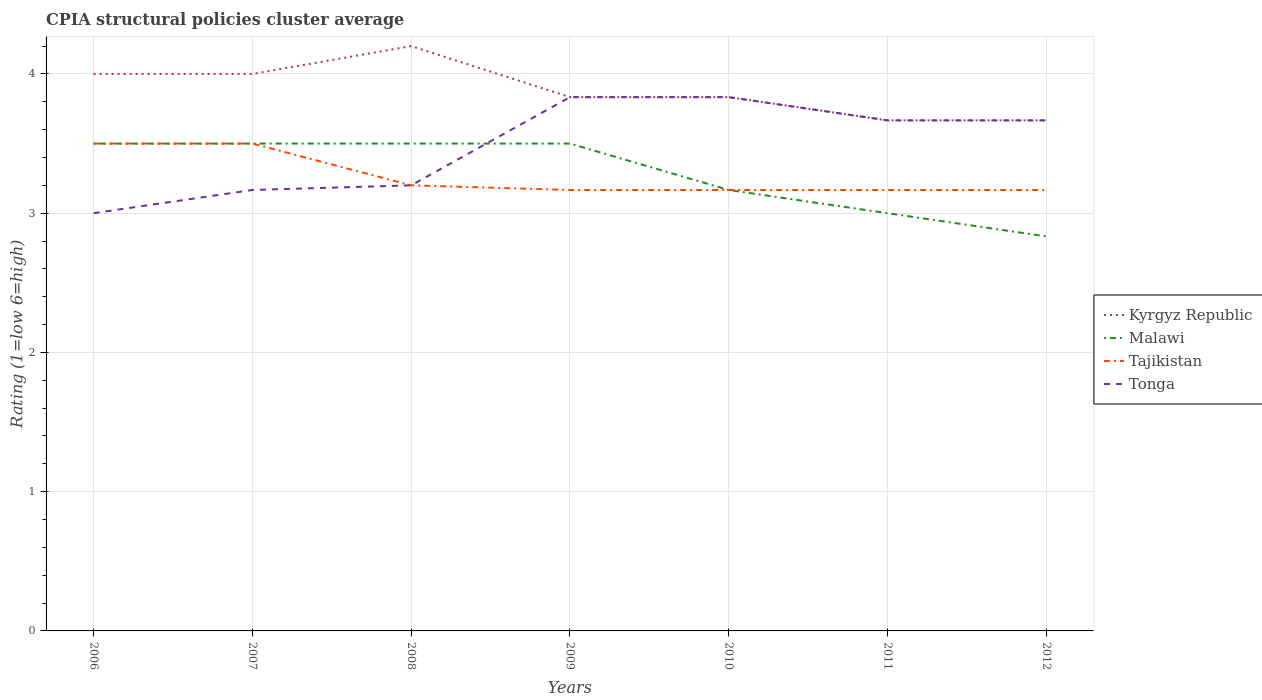Does the line corresponding to Malawi intersect with the line corresponding to Kyrgyz Republic?
Your answer should be very brief. No. Across all years, what is the maximum CPIA rating in Kyrgyz Republic?
Offer a very short reply. 3.67. In which year was the CPIA rating in Tajikistan maximum?
Ensure brevity in your answer.  2009. What is the difference between the highest and the second highest CPIA rating in Kyrgyz Republic?
Your response must be concise. 0.53. Is the CPIA rating in Kyrgyz Republic strictly greater than the CPIA rating in Tajikistan over the years?
Provide a succinct answer. No. How many years are there in the graph?
Your response must be concise. 7. What is the difference between two consecutive major ticks on the Y-axis?
Offer a terse response. 1. Does the graph contain any zero values?
Your answer should be very brief. No. Where does the legend appear in the graph?
Keep it short and to the point. Center right. How are the legend labels stacked?
Offer a terse response. Vertical. What is the title of the graph?
Ensure brevity in your answer.  CPIA structural policies cluster average. What is the label or title of the Y-axis?
Provide a succinct answer. Rating (1=low 6=high). What is the Rating (1=low 6=high) in Malawi in 2006?
Offer a terse response. 3.5. What is the Rating (1=low 6=high) in Tajikistan in 2006?
Keep it short and to the point. 3.5. What is the Rating (1=low 6=high) of Tonga in 2006?
Ensure brevity in your answer.  3. What is the Rating (1=low 6=high) of Kyrgyz Republic in 2007?
Your response must be concise. 4. What is the Rating (1=low 6=high) in Malawi in 2007?
Make the answer very short. 3.5. What is the Rating (1=low 6=high) of Tajikistan in 2007?
Provide a short and direct response. 3.5. What is the Rating (1=low 6=high) in Tonga in 2007?
Provide a succinct answer. 3.17. What is the Rating (1=low 6=high) in Kyrgyz Republic in 2008?
Give a very brief answer. 4.2. What is the Rating (1=low 6=high) in Kyrgyz Republic in 2009?
Keep it short and to the point. 3.83. What is the Rating (1=low 6=high) of Tajikistan in 2009?
Your answer should be very brief. 3.17. What is the Rating (1=low 6=high) in Tonga in 2009?
Make the answer very short. 3.83. What is the Rating (1=low 6=high) in Kyrgyz Republic in 2010?
Ensure brevity in your answer.  3.83. What is the Rating (1=low 6=high) in Malawi in 2010?
Provide a succinct answer. 3.17. What is the Rating (1=low 6=high) in Tajikistan in 2010?
Ensure brevity in your answer.  3.17. What is the Rating (1=low 6=high) of Tonga in 2010?
Give a very brief answer. 3.83. What is the Rating (1=low 6=high) of Kyrgyz Republic in 2011?
Give a very brief answer. 3.67. What is the Rating (1=low 6=high) of Malawi in 2011?
Your answer should be compact. 3. What is the Rating (1=low 6=high) of Tajikistan in 2011?
Your answer should be very brief. 3.17. What is the Rating (1=low 6=high) of Tonga in 2011?
Provide a succinct answer. 3.67. What is the Rating (1=low 6=high) in Kyrgyz Republic in 2012?
Ensure brevity in your answer.  3.67. What is the Rating (1=low 6=high) of Malawi in 2012?
Offer a very short reply. 2.83. What is the Rating (1=low 6=high) of Tajikistan in 2012?
Your response must be concise. 3.17. What is the Rating (1=low 6=high) of Tonga in 2012?
Your answer should be very brief. 3.67. Across all years, what is the maximum Rating (1=low 6=high) of Kyrgyz Republic?
Provide a short and direct response. 4.2. Across all years, what is the maximum Rating (1=low 6=high) of Tajikistan?
Your response must be concise. 3.5. Across all years, what is the maximum Rating (1=low 6=high) in Tonga?
Offer a terse response. 3.83. Across all years, what is the minimum Rating (1=low 6=high) of Kyrgyz Republic?
Provide a short and direct response. 3.67. Across all years, what is the minimum Rating (1=low 6=high) of Malawi?
Offer a terse response. 2.83. Across all years, what is the minimum Rating (1=low 6=high) in Tajikistan?
Make the answer very short. 3.17. What is the total Rating (1=low 6=high) of Kyrgyz Republic in the graph?
Give a very brief answer. 27.2. What is the total Rating (1=low 6=high) of Tajikistan in the graph?
Keep it short and to the point. 22.87. What is the total Rating (1=low 6=high) in Tonga in the graph?
Ensure brevity in your answer.  24.37. What is the difference between the Rating (1=low 6=high) in Malawi in 2006 and that in 2007?
Your answer should be very brief. 0. What is the difference between the Rating (1=low 6=high) of Tajikistan in 2006 and that in 2007?
Make the answer very short. 0. What is the difference between the Rating (1=low 6=high) in Tonga in 2006 and that in 2007?
Your response must be concise. -0.17. What is the difference between the Rating (1=low 6=high) in Malawi in 2006 and that in 2008?
Provide a succinct answer. 0. What is the difference between the Rating (1=low 6=high) in Tonga in 2006 and that in 2008?
Your response must be concise. -0.2. What is the difference between the Rating (1=low 6=high) of Malawi in 2006 and that in 2009?
Offer a terse response. 0. What is the difference between the Rating (1=low 6=high) in Kyrgyz Republic in 2006 and that in 2010?
Your response must be concise. 0.17. What is the difference between the Rating (1=low 6=high) in Tajikistan in 2006 and that in 2010?
Your response must be concise. 0.33. What is the difference between the Rating (1=low 6=high) in Kyrgyz Republic in 2006 and that in 2011?
Provide a succinct answer. 0.33. What is the difference between the Rating (1=low 6=high) of Malawi in 2006 and that in 2011?
Your answer should be compact. 0.5. What is the difference between the Rating (1=low 6=high) of Tonga in 2006 and that in 2011?
Provide a succinct answer. -0.67. What is the difference between the Rating (1=low 6=high) in Malawi in 2006 and that in 2012?
Your response must be concise. 0.67. What is the difference between the Rating (1=low 6=high) in Tonga in 2006 and that in 2012?
Your response must be concise. -0.67. What is the difference between the Rating (1=low 6=high) of Tajikistan in 2007 and that in 2008?
Your answer should be compact. 0.3. What is the difference between the Rating (1=low 6=high) in Tonga in 2007 and that in 2008?
Provide a succinct answer. -0.03. What is the difference between the Rating (1=low 6=high) in Kyrgyz Republic in 2007 and that in 2009?
Provide a succinct answer. 0.17. What is the difference between the Rating (1=low 6=high) of Tajikistan in 2007 and that in 2009?
Offer a terse response. 0.33. What is the difference between the Rating (1=low 6=high) of Tonga in 2007 and that in 2009?
Ensure brevity in your answer.  -0.67. What is the difference between the Rating (1=low 6=high) in Tajikistan in 2007 and that in 2010?
Make the answer very short. 0.33. What is the difference between the Rating (1=low 6=high) in Tonga in 2007 and that in 2010?
Your answer should be compact. -0.67. What is the difference between the Rating (1=low 6=high) in Kyrgyz Republic in 2007 and that in 2011?
Your response must be concise. 0.33. What is the difference between the Rating (1=low 6=high) in Malawi in 2007 and that in 2011?
Offer a terse response. 0.5. What is the difference between the Rating (1=low 6=high) of Tonga in 2007 and that in 2011?
Give a very brief answer. -0.5. What is the difference between the Rating (1=low 6=high) in Malawi in 2007 and that in 2012?
Your response must be concise. 0.67. What is the difference between the Rating (1=low 6=high) in Kyrgyz Republic in 2008 and that in 2009?
Give a very brief answer. 0.37. What is the difference between the Rating (1=low 6=high) in Tajikistan in 2008 and that in 2009?
Your answer should be compact. 0.03. What is the difference between the Rating (1=low 6=high) in Tonga in 2008 and that in 2009?
Ensure brevity in your answer.  -0.63. What is the difference between the Rating (1=low 6=high) of Kyrgyz Republic in 2008 and that in 2010?
Your response must be concise. 0.37. What is the difference between the Rating (1=low 6=high) of Malawi in 2008 and that in 2010?
Offer a terse response. 0.33. What is the difference between the Rating (1=low 6=high) in Tajikistan in 2008 and that in 2010?
Your answer should be compact. 0.03. What is the difference between the Rating (1=low 6=high) in Tonga in 2008 and that in 2010?
Ensure brevity in your answer.  -0.63. What is the difference between the Rating (1=low 6=high) of Kyrgyz Republic in 2008 and that in 2011?
Provide a short and direct response. 0.53. What is the difference between the Rating (1=low 6=high) in Malawi in 2008 and that in 2011?
Your response must be concise. 0.5. What is the difference between the Rating (1=low 6=high) of Tonga in 2008 and that in 2011?
Provide a succinct answer. -0.47. What is the difference between the Rating (1=low 6=high) in Kyrgyz Republic in 2008 and that in 2012?
Ensure brevity in your answer.  0.53. What is the difference between the Rating (1=low 6=high) of Tonga in 2008 and that in 2012?
Your response must be concise. -0.47. What is the difference between the Rating (1=low 6=high) in Kyrgyz Republic in 2009 and that in 2010?
Offer a terse response. 0. What is the difference between the Rating (1=low 6=high) of Kyrgyz Republic in 2009 and that in 2011?
Ensure brevity in your answer.  0.17. What is the difference between the Rating (1=low 6=high) of Tajikistan in 2009 and that in 2011?
Ensure brevity in your answer.  0. What is the difference between the Rating (1=low 6=high) in Tonga in 2009 and that in 2011?
Your response must be concise. 0.17. What is the difference between the Rating (1=low 6=high) of Tonga in 2009 and that in 2012?
Provide a short and direct response. 0.17. What is the difference between the Rating (1=low 6=high) in Malawi in 2010 and that in 2011?
Give a very brief answer. 0.17. What is the difference between the Rating (1=low 6=high) of Tajikistan in 2010 and that in 2011?
Offer a terse response. 0. What is the difference between the Rating (1=low 6=high) in Tonga in 2010 and that in 2011?
Give a very brief answer. 0.17. What is the difference between the Rating (1=low 6=high) of Malawi in 2010 and that in 2012?
Your answer should be compact. 0.33. What is the difference between the Rating (1=low 6=high) in Tajikistan in 2010 and that in 2012?
Make the answer very short. 0. What is the difference between the Rating (1=low 6=high) in Kyrgyz Republic in 2011 and that in 2012?
Provide a short and direct response. 0. What is the difference between the Rating (1=low 6=high) of Malawi in 2011 and that in 2012?
Offer a very short reply. 0.17. What is the difference between the Rating (1=low 6=high) of Tonga in 2011 and that in 2012?
Your answer should be very brief. 0. What is the difference between the Rating (1=low 6=high) of Kyrgyz Republic in 2006 and the Rating (1=low 6=high) of Tajikistan in 2007?
Offer a terse response. 0.5. What is the difference between the Rating (1=low 6=high) of Malawi in 2006 and the Rating (1=low 6=high) of Tonga in 2007?
Provide a succinct answer. 0.33. What is the difference between the Rating (1=low 6=high) in Kyrgyz Republic in 2006 and the Rating (1=low 6=high) in Tonga in 2008?
Ensure brevity in your answer.  0.8. What is the difference between the Rating (1=low 6=high) of Malawi in 2006 and the Rating (1=low 6=high) of Tajikistan in 2008?
Your response must be concise. 0.3. What is the difference between the Rating (1=low 6=high) in Malawi in 2006 and the Rating (1=low 6=high) in Tonga in 2008?
Give a very brief answer. 0.3. What is the difference between the Rating (1=low 6=high) of Kyrgyz Republic in 2006 and the Rating (1=low 6=high) of Tajikistan in 2009?
Your answer should be compact. 0.83. What is the difference between the Rating (1=low 6=high) in Malawi in 2006 and the Rating (1=low 6=high) in Tajikistan in 2009?
Your answer should be compact. 0.33. What is the difference between the Rating (1=low 6=high) in Tajikistan in 2006 and the Rating (1=low 6=high) in Tonga in 2009?
Offer a very short reply. -0.33. What is the difference between the Rating (1=low 6=high) of Kyrgyz Republic in 2006 and the Rating (1=low 6=high) of Tonga in 2010?
Give a very brief answer. 0.17. What is the difference between the Rating (1=low 6=high) of Kyrgyz Republic in 2006 and the Rating (1=low 6=high) of Malawi in 2011?
Your answer should be compact. 1. What is the difference between the Rating (1=low 6=high) of Kyrgyz Republic in 2006 and the Rating (1=low 6=high) of Tonga in 2011?
Offer a very short reply. 0.33. What is the difference between the Rating (1=low 6=high) in Malawi in 2006 and the Rating (1=low 6=high) in Tajikistan in 2011?
Offer a terse response. 0.33. What is the difference between the Rating (1=low 6=high) in Malawi in 2006 and the Rating (1=low 6=high) in Tonga in 2011?
Ensure brevity in your answer.  -0.17. What is the difference between the Rating (1=low 6=high) of Kyrgyz Republic in 2006 and the Rating (1=low 6=high) of Malawi in 2012?
Provide a short and direct response. 1.17. What is the difference between the Rating (1=low 6=high) in Malawi in 2006 and the Rating (1=low 6=high) in Tajikistan in 2012?
Provide a short and direct response. 0.33. What is the difference between the Rating (1=low 6=high) in Tajikistan in 2006 and the Rating (1=low 6=high) in Tonga in 2012?
Your response must be concise. -0.17. What is the difference between the Rating (1=low 6=high) of Kyrgyz Republic in 2007 and the Rating (1=low 6=high) of Malawi in 2008?
Keep it short and to the point. 0.5. What is the difference between the Rating (1=low 6=high) in Kyrgyz Republic in 2007 and the Rating (1=low 6=high) in Tajikistan in 2008?
Provide a succinct answer. 0.8. What is the difference between the Rating (1=low 6=high) of Kyrgyz Republic in 2007 and the Rating (1=low 6=high) of Tonga in 2008?
Provide a short and direct response. 0.8. What is the difference between the Rating (1=low 6=high) in Malawi in 2007 and the Rating (1=low 6=high) in Tajikistan in 2008?
Offer a terse response. 0.3. What is the difference between the Rating (1=low 6=high) of Kyrgyz Republic in 2007 and the Rating (1=low 6=high) of Tonga in 2009?
Offer a terse response. 0.17. What is the difference between the Rating (1=low 6=high) in Tajikistan in 2007 and the Rating (1=low 6=high) in Tonga in 2009?
Give a very brief answer. -0.33. What is the difference between the Rating (1=low 6=high) of Kyrgyz Republic in 2007 and the Rating (1=low 6=high) of Tajikistan in 2010?
Provide a succinct answer. 0.83. What is the difference between the Rating (1=low 6=high) of Kyrgyz Republic in 2007 and the Rating (1=low 6=high) of Tonga in 2010?
Provide a short and direct response. 0.17. What is the difference between the Rating (1=low 6=high) in Kyrgyz Republic in 2007 and the Rating (1=low 6=high) in Malawi in 2011?
Your answer should be very brief. 1. What is the difference between the Rating (1=low 6=high) in Kyrgyz Republic in 2007 and the Rating (1=low 6=high) in Tajikistan in 2011?
Offer a terse response. 0.83. What is the difference between the Rating (1=low 6=high) in Kyrgyz Republic in 2007 and the Rating (1=low 6=high) in Tajikistan in 2012?
Provide a succinct answer. 0.83. What is the difference between the Rating (1=low 6=high) in Kyrgyz Republic in 2007 and the Rating (1=low 6=high) in Tonga in 2012?
Make the answer very short. 0.33. What is the difference between the Rating (1=low 6=high) in Malawi in 2007 and the Rating (1=low 6=high) in Tajikistan in 2012?
Provide a short and direct response. 0.33. What is the difference between the Rating (1=low 6=high) in Malawi in 2007 and the Rating (1=low 6=high) in Tonga in 2012?
Keep it short and to the point. -0.17. What is the difference between the Rating (1=low 6=high) of Kyrgyz Republic in 2008 and the Rating (1=low 6=high) of Tonga in 2009?
Your answer should be compact. 0.37. What is the difference between the Rating (1=low 6=high) of Tajikistan in 2008 and the Rating (1=low 6=high) of Tonga in 2009?
Provide a short and direct response. -0.63. What is the difference between the Rating (1=low 6=high) in Kyrgyz Republic in 2008 and the Rating (1=low 6=high) in Malawi in 2010?
Keep it short and to the point. 1.03. What is the difference between the Rating (1=low 6=high) of Kyrgyz Republic in 2008 and the Rating (1=low 6=high) of Tonga in 2010?
Ensure brevity in your answer.  0.37. What is the difference between the Rating (1=low 6=high) of Malawi in 2008 and the Rating (1=low 6=high) of Tajikistan in 2010?
Give a very brief answer. 0.33. What is the difference between the Rating (1=low 6=high) in Malawi in 2008 and the Rating (1=low 6=high) in Tonga in 2010?
Offer a terse response. -0.33. What is the difference between the Rating (1=low 6=high) of Tajikistan in 2008 and the Rating (1=low 6=high) of Tonga in 2010?
Offer a terse response. -0.63. What is the difference between the Rating (1=low 6=high) of Kyrgyz Republic in 2008 and the Rating (1=low 6=high) of Malawi in 2011?
Ensure brevity in your answer.  1.2. What is the difference between the Rating (1=low 6=high) in Kyrgyz Republic in 2008 and the Rating (1=low 6=high) in Tajikistan in 2011?
Offer a terse response. 1.03. What is the difference between the Rating (1=low 6=high) in Kyrgyz Republic in 2008 and the Rating (1=low 6=high) in Tonga in 2011?
Give a very brief answer. 0.53. What is the difference between the Rating (1=low 6=high) in Malawi in 2008 and the Rating (1=low 6=high) in Tajikistan in 2011?
Ensure brevity in your answer.  0.33. What is the difference between the Rating (1=low 6=high) in Tajikistan in 2008 and the Rating (1=low 6=high) in Tonga in 2011?
Your response must be concise. -0.47. What is the difference between the Rating (1=low 6=high) in Kyrgyz Republic in 2008 and the Rating (1=low 6=high) in Malawi in 2012?
Your response must be concise. 1.37. What is the difference between the Rating (1=low 6=high) of Kyrgyz Republic in 2008 and the Rating (1=low 6=high) of Tajikistan in 2012?
Provide a short and direct response. 1.03. What is the difference between the Rating (1=low 6=high) in Kyrgyz Republic in 2008 and the Rating (1=low 6=high) in Tonga in 2012?
Keep it short and to the point. 0.53. What is the difference between the Rating (1=low 6=high) in Malawi in 2008 and the Rating (1=low 6=high) in Tajikistan in 2012?
Keep it short and to the point. 0.33. What is the difference between the Rating (1=low 6=high) in Malawi in 2008 and the Rating (1=low 6=high) in Tonga in 2012?
Your answer should be very brief. -0.17. What is the difference between the Rating (1=low 6=high) in Tajikistan in 2008 and the Rating (1=low 6=high) in Tonga in 2012?
Ensure brevity in your answer.  -0.47. What is the difference between the Rating (1=low 6=high) of Kyrgyz Republic in 2009 and the Rating (1=low 6=high) of Tajikistan in 2010?
Offer a very short reply. 0.67. What is the difference between the Rating (1=low 6=high) in Malawi in 2009 and the Rating (1=low 6=high) in Tajikistan in 2010?
Provide a succinct answer. 0.33. What is the difference between the Rating (1=low 6=high) of Tajikistan in 2009 and the Rating (1=low 6=high) of Tonga in 2010?
Provide a short and direct response. -0.67. What is the difference between the Rating (1=low 6=high) of Kyrgyz Republic in 2009 and the Rating (1=low 6=high) of Malawi in 2011?
Give a very brief answer. 0.83. What is the difference between the Rating (1=low 6=high) in Kyrgyz Republic in 2009 and the Rating (1=low 6=high) in Tajikistan in 2011?
Offer a terse response. 0.67. What is the difference between the Rating (1=low 6=high) in Malawi in 2009 and the Rating (1=low 6=high) in Tonga in 2011?
Your response must be concise. -0.17. What is the difference between the Rating (1=low 6=high) in Kyrgyz Republic in 2009 and the Rating (1=low 6=high) in Malawi in 2012?
Ensure brevity in your answer.  1. What is the difference between the Rating (1=low 6=high) in Kyrgyz Republic in 2009 and the Rating (1=low 6=high) in Tajikistan in 2012?
Ensure brevity in your answer.  0.67. What is the difference between the Rating (1=low 6=high) in Malawi in 2009 and the Rating (1=low 6=high) in Tajikistan in 2012?
Offer a terse response. 0.33. What is the difference between the Rating (1=low 6=high) in Tajikistan in 2009 and the Rating (1=low 6=high) in Tonga in 2012?
Offer a terse response. -0.5. What is the difference between the Rating (1=low 6=high) of Kyrgyz Republic in 2010 and the Rating (1=low 6=high) of Tonga in 2011?
Ensure brevity in your answer.  0.17. What is the difference between the Rating (1=low 6=high) of Malawi in 2010 and the Rating (1=low 6=high) of Tajikistan in 2011?
Your answer should be very brief. 0. What is the difference between the Rating (1=low 6=high) in Malawi in 2010 and the Rating (1=low 6=high) in Tonga in 2011?
Provide a succinct answer. -0.5. What is the difference between the Rating (1=low 6=high) of Malawi in 2010 and the Rating (1=low 6=high) of Tajikistan in 2012?
Offer a terse response. 0. What is the difference between the Rating (1=low 6=high) of Malawi in 2010 and the Rating (1=low 6=high) of Tonga in 2012?
Your answer should be very brief. -0.5. What is the difference between the Rating (1=low 6=high) in Tajikistan in 2010 and the Rating (1=low 6=high) in Tonga in 2012?
Make the answer very short. -0.5. What is the difference between the Rating (1=low 6=high) of Kyrgyz Republic in 2011 and the Rating (1=low 6=high) of Malawi in 2012?
Provide a succinct answer. 0.83. What is the difference between the Rating (1=low 6=high) of Kyrgyz Republic in 2011 and the Rating (1=low 6=high) of Tajikistan in 2012?
Keep it short and to the point. 0.5. What is the difference between the Rating (1=low 6=high) in Tajikistan in 2011 and the Rating (1=low 6=high) in Tonga in 2012?
Provide a short and direct response. -0.5. What is the average Rating (1=low 6=high) of Kyrgyz Republic per year?
Provide a short and direct response. 3.89. What is the average Rating (1=low 6=high) of Malawi per year?
Your response must be concise. 3.29. What is the average Rating (1=low 6=high) of Tajikistan per year?
Make the answer very short. 3.27. What is the average Rating (1=low 6=high) in Tonga per year?
Provide a succinct answer. 3.48. In the year 2006, what is the difference between the Rating (1=low 6=high) of Kyrgyz Republic and Rating (1=low 6=high) of Malawi?
Keep it short and to the point. 0.5. In the year 2006, what is the difference between the Rating (1=low 6=high) of Kyrgyz Republic and Rating (1=low 6=high) of Tonga?
Your answer should be compact. 1. In the year 2006, what is the difference between the Rating (1=low 6=high) in Malawi and Rating (1=low 6=high) in Tonga?
Your response must be concise. 0.5. In the year 2007, what is the difference between the Rating (1=low 6=high) in Kyrgyz Republic and Rating (1=low 6=high) in Tajikistan?
Provide a succinct answer. 0.5. In the year 2007, what is the difference between the Rating (1=low 6=high) in Kyrgyz Republic and Rating (1=low 6=high) in Tonga?
Your answer should be very brief. 0.83. In the year 2007, what is the difference between the Rating (1=low 6=high) of Malawi and Rating (1=low 6=high) of Tajikistan?
Your response must be concise. 0. In the year 2008, what is the difference between the Rating (1=low 6=high) of Kyrgyz Republic and Rating (1=low 6=high) of Malawi?
Your answer should be very brief. 0.7. In the year 2008, what is the difference between the Rating (1=low 6=high) in Kyrgyz Republic and Rating (1=low 6=high) in Tajikistan?
Offer a very short reply. 1. In the year 2008, what is the difference between the Rating (1=low 6=high) of Kyrgyz Republic and Rating (1=low 6=high) of Tonga?
Give a very brief answer. 1. In the year 2008, what is the difference between the Rating (1=low 6=high) in Malawi and Rating (1=low 6=high) in Tajikistan?
Provide a succinct answer. 0.3. In the year 2008, what is the difference between the Rating (1=low 6=high) in Malawi and Rating (1=low 6=high) in Tonga?
Make the answer very short. 0.3. In the year 2009, what is the difference between the Rating (1=low 6=high) of Kyrgyz Republic and Rating (1=low 6=high) of Tonga?
Offer a terse response. 0. In the year 2009, what is the difference between the Rating (1=low 6=high) in Malawi and Rating (1=low 6=high) in Tonga?
Make the answer very short. -0.33. In the year 2009, what is the difference between the Rating (1=low 6=high) of Tajikistan and Rating (1=low 6=high) of Tonga?
Your answer should be compact. -0.67. In the year 2010, what is the difference between the Rating (1=low 6=high) in Malawi and Rating (1=low 6=high) in Tonga?
Your answer should be very brief. -0.67. In the year 2010, what is the difference between the Rating (1=low 6=high) in Tajikistan and Rating (1=low 6=high) in Tonga?
Offer a very short reply. -0.67. In the year 2011, what is the difference between the Rating (1=low 6=high) of Kyrgyz Republic and Rating (1=low 6=high) of Tajikistan?
Give a very brief answer. 0.5. In the year 2011, what is the difference between the Rating (1=low 6=high) of Malawi and Rating (1=low 6=high) of Tonga?
Your answer should be compact. -0.67. In the year 2011, what is the difference between the Rating (1=low 6=high) of Tajikistan and Rating (1=low 6=high) of Tonga?
Make the answer very short. -0.5. In the year 2012, what is the difference between the Rating (1=low 6=high) of Malawi and Rating (1=low 6=high) of Tonga?
Keep it short and to the point. -0.83. What is the ratio of the Rating (1=low 6=high) in Kyrgyz Republic in 2006 to that in 2007?
Provide a short and direct response. 1. What is the ratio of the Rating (1=low 6=high) in Malawi in 2006 to that in 2007?
Provide a short and direct response. 1. What is the ratio of the Rating (1=low 6=high) of Tajikistan in 2006 to that in 2007?
Offer a very short reply. 1. What is the ratio of the Rating (1=low 6=high) of Tajikistan in 2006 to that in 2008?
Offer a terse response. 1.09. What is the ratio of the Rating (1=low 6=high) of Kyrgyz Republic in 2006 to that in 2009?
Keep it short and to the point. 1.04. What is the ratio of the Rating (1=low 6=high) of Malawi in 2006 to that in 2009?
Give a very brief answer. 1. What is the ratio of the Rating (1=low 6=high) of Tajikistan in 2006 to that in 2009?
Ensure brevity in your answer.  1.11. What is the ratio of the Rating (1=low 6=high) in Tonga in 2006 to that in 2009?
Ensure brevity in your answer.  0.78. What is the ratio of the Rating (1=low 6=high) of Kyrgyz Republic in 2006 to that in 2010?
Your answer should be very brief. 1.04. What is the ratio of the Rating (1=low 6=high) in Malawi in 2006 to that in 2010?
Ensure brevity in your answer.  1.11. What is the ratio of the Rating (1=low 6=high) of Tajikistan in 2006 to that in 2010?
Your response must be concise. 1.11. What is the ratio of the Rating (1=low 6=high) of Tonga in 2006 to that in 2010?
Offer a terse response. 0.78. What is the ratio of the Rating (1=low 6=high) in Tajikistan in 2006 to that in 2011?
Your response must be concise. 1.11. What is the ratio of the Rating (1=low 6=high) of Tonga in 2006 to that in 2011?
Your answer should be compact. 0.82. What is the ratio of the Rating (1=low 6=high) of Malawi in 2006 to that in 2012?
Your answer should be compact. 1.24. What is the ratio of the Rating (1=low 6=high) in Tajikistan in 2006 to that in 2012?
Make the answer very short. 1.11. What is the ratio of the Rating (1=low 6=high) in Tonga in 2006 to that in 2012?
Make the answer very short. 0.82. What is the ratio of the Rating (1=low 6=high) in Kyrgyz Republic in 2007 to that in 2008?
Offer a very short reply. 0.95. What is the ratio of the Rating (1=low 6=high) in Tajikistan in 2007 to that in 2008?
Your answer should be very brief. 1.09. What is the ratio of the Rating (1=low 6=high) of Kyrgyz Republic in 2007 to that in 2009?
Provide a succinct answer. 1.04. What is the ratio of the Rating (1=low 6=high) in Tajikistan in 2007 to that in 2009?
Your answer should be compact. 1.11. What is the ratio of the Rating (1=low 6=high) in Tonga in 2007 to that in 2009?
Your answer should be very brief. 0.83. What is the ratio of the Rating (1=low 6=high) of Kyrgyz Republic in 2007 to that in 2010?
Make the answer very short. 1.04. What is the ratio of the Rating (1=low 6=high) of Malawi in 2007 to that in 2010?
Your answer should be very brief. 1.11. What is the ratio of the Rating (1=low 6=high) in Tajikistan in 2007 to that in 2010?
Provide a succinct answer. 1.11. What is the ratio of the Rating (1=low 6=high) of Tonga in 2007 to that in 2010?
Your answer should be compact. 0.83. What is the ratio of the Rating (1=low 6=high) of Kyrgyz Republic in 2007 to that in 2011?
Give a very brief answer. 1.09. What is the ratio of the Rating (1=low 6=high) of Malawi in 2007 to that in 2011?
Provide a short and direct response. 1.17. What is the ratio of the Rating (1=low 6=high) of Tajikistan in 2007 to that in 2011?
Your answer should be compact. 1.11. What is the ratio of the Rating (1=low 6=high) of Tonga in 2007 to that in 2011?
Keep it short and to the point. 0.86. What is the ratio of the Rating (1=low 6=high) of Malawi in 2007 to that in 2012?
Make the answer very short. 1.24. What is the ratio of the Rating (1=low 6=high) of Tajikistan in 2007 to that in 2012?
Your response must be concise. 1.11. What is the ratio of the Rating (1=low 6=high) in Tonga in 2007 to that in 2012?
Your response must be concise. 0.86. What is the ratio of the Rating (1=low 6=high) in Kyrgyz Republic in 2008 to that in 2009?
Give a very brief answer. 1.1. What is the ratio of the Rating (1=low 6=high) of Malawi in 2008 to that in 2009?
Provide a short and direct response. 1. What is the ratio of the Rating (1=low 6=high) of Tajikistan in 2008 to that in 2009?
Offer a terse response. 1.01. What is the ratio of the Rating (1=low 6=high) of Tonga in 2008 to that in 2009?
Your response must be concise. 0.83. What is the ratio of the Rating (1=low 6=high) of Kyrgyz Republic in 2008 to that in 2010?
Keep it short and to the point. 1.1. What is the ratio of the Rating (1=low 6=high) in Malawi in 2008 to that in 2010?
Your answer should be compact. 1.11. What is the ratio of the Rating (1=low 6=high) of Tajikistan in 2008 to that in 2010?
Provide a succinct answer. 1.01. What is the ratio of the Rating (1=low 6=high) of Tonga in 2008 to that in 2010?
Your answer should be very brief. 0.83. What is the ratio of the Rating (1=low 6=high) of Kyrgyz Republic in 2008 to that in 2011?
Ensure brevity in your answer.  1.15. What is the ratio of the Rating (1=low 6=high) in Malawi in 2008 to that in 2011?
Provide a short and direct response. 1.17. What is the ratio of the Rating (1=low 6=high) of Tajikistan in 2008 to that in 2011?
Give a very brief answer. 1.01. What is the ratio of the Rating (1=low 6=high) of Tonga in 2008 to that in 2011?
Ensure brevity in your answer.  0.87. What is the ratio of the Rating (1=low 6=high) of Kyrgyz Republic in 2008 to that in 2012?
Keep it short and to the point. 1.15. What is the ratio of the Rating (1=low 6=high) in Malawi in 2008 to that in 2012?
Offer a terse response. 1.24. What is the ratio of the Rating (1=low 6=high) in Tajikistan in 2008 to that in 2012?
Provide a succinct answer. 1.01. What is the ratio of the Rating (1=low 6=high) of Tonga in 2008 to that in 2012?
Your response must be concise. 0.87. What is the ratio of the Rating (1=low 6=high) of Kyrgyz Republic in 2009 to that in 2010?
Provide a short and direct response. 1. What is the ratio of the Rating (1=low 6=high) of Malawi in 2009 to that in 2010?
Ensure brevity in your answer.  1.11. What is the ratio of the Rating (1=low 6=high) in Kyrgyz Republic in 2009 to that in 2011?
Keep it short and to the point. 1.05. What is the ratio of the Rating (1=low 6=high) in Tonga in 2009 to that in 2011?
Make the answer very short. 1.05. What is the ratio of the Rating (1=low 6=high) of Kyrgyz Republic in 2009 to that in 2012?
Your answer should be compact. 1.05. What is the ratio of the Rating (1=low 6=high) of Malawi in 2009 to that in 2012?
Offer a terse response. 1.24. What is the ratio of the Rating (1=low 6=high) in Tonga in 2009 to that in 2012?
Your answer should be compact. 1.05. What is the ratio of the Rating (1=low 6=high) of Kyrgyz Republic in 2010 to that in 2011?
Your answer should be compact. 1.05. What is the ratio of the Rating (1=low 6=high) of Malawi in 2010 to that in 2011?
Offer a terse response. 1.06. What is the ratio of the Rating (1=low 6=high) of Tajikistan in 2010 to that in 2011?
Keep it short and to the point. 1. What is the ratio of the Rating (1=low 6=high) of Tonga in 2010 to that in 2011?
Your answer should be very brief. 1.05. What is the ratio of the Rating (1=low 6=high) of Kyrgyz Republic in 2010 to that in 2012?
Keep it short and to the point. 1.05. What is the ratio of the Rating (1=low 6=high) of Malawi in 2010 to that in 2012?
Your response must be concise. 1.12. What is the ratio of the Rating (1=low 6=high) in Tonga in 2010 to that in 2012?
Give a very brief answer. 1.05. What is the ratio of the Rating (1=low 6=high) in Malawi in 2011 to that in 2012?
Your answer should be compact. 1.06. What is the ratio of the Rating (1=low 6=high) in Tonga in 2011 to that in 2012?
Your answer should be compact. 1. What is the difference between the highest and the second highest Rating (1=low 6=high) of Malawi?
Keep it short and to the point. 0. What is the difference between the highest and the second highest Rating (1=low 6=high) in Tajikistan?
Make the answer very short. 0. What is the difference between the highest and the second highest Rating (1=low 6=high) of Tonga?
Ensure brevity in your answer.  0. What is the difference between the highest and the lowest Rating (1=low 6=high) in Kyrgyz Republic?
Offer a terse response. 0.53. What is the difference between the highest and the lowest Rating (1=low 6=high) in Malawi?
Provide a short and direct response. 0.67. What is the difference between the highest and the lowest Rating (1=low 6=high) of Tonga?
Keep it short and to the point. 0.83. 